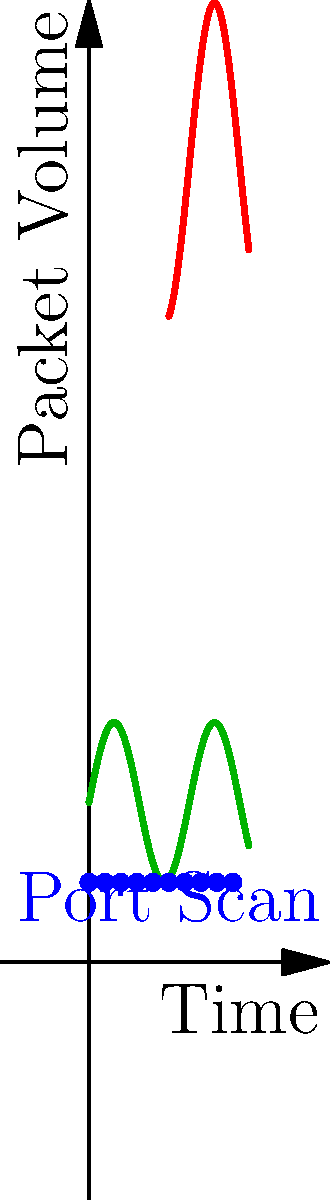Based on the visual representation of network traffic patterns shown in the graph, identify the type of network attack occurring between time 5 and 10 on the x-axis, and explain why this pattern is indicative of that specific attack. To identify the type of network attack, let's analyze the graph step-by-step:

1. Normal traffic (green line):
   - Shows a consistent, low-volume pattern with small fluctuations.
   - This represents typical network behavior.

2. Blue dots at the bottom:
   - Represent a series of low-volume, evenly spaced packets.
   - This pattern is characteristic of a port scan, where an attacker probes various ports.

3. Red line (between time 5 and 10):
   - Shows a sudden, significant increase in packet volume.
   - The volume is much higher than normal traffic and maintains this high level.
   - This pattern is indicative of a Distributed Denial of Service (DDoS) attack.

The question specifically asks about the attack between time 5 and 10. The red line in this time frame shows:
   a) An abrupt increase in packet volume.
   b) Sustained high traffic levels.
   c) Volume significantly higher than normal traffic.

These characteristics are typical of a DDoS attack, where multiple sources flood the network with a high volume of packets, aiming to overwhelm the system and deny service to legitimate users.
Answer: DDoS (Distributed Denial of Service) attack 